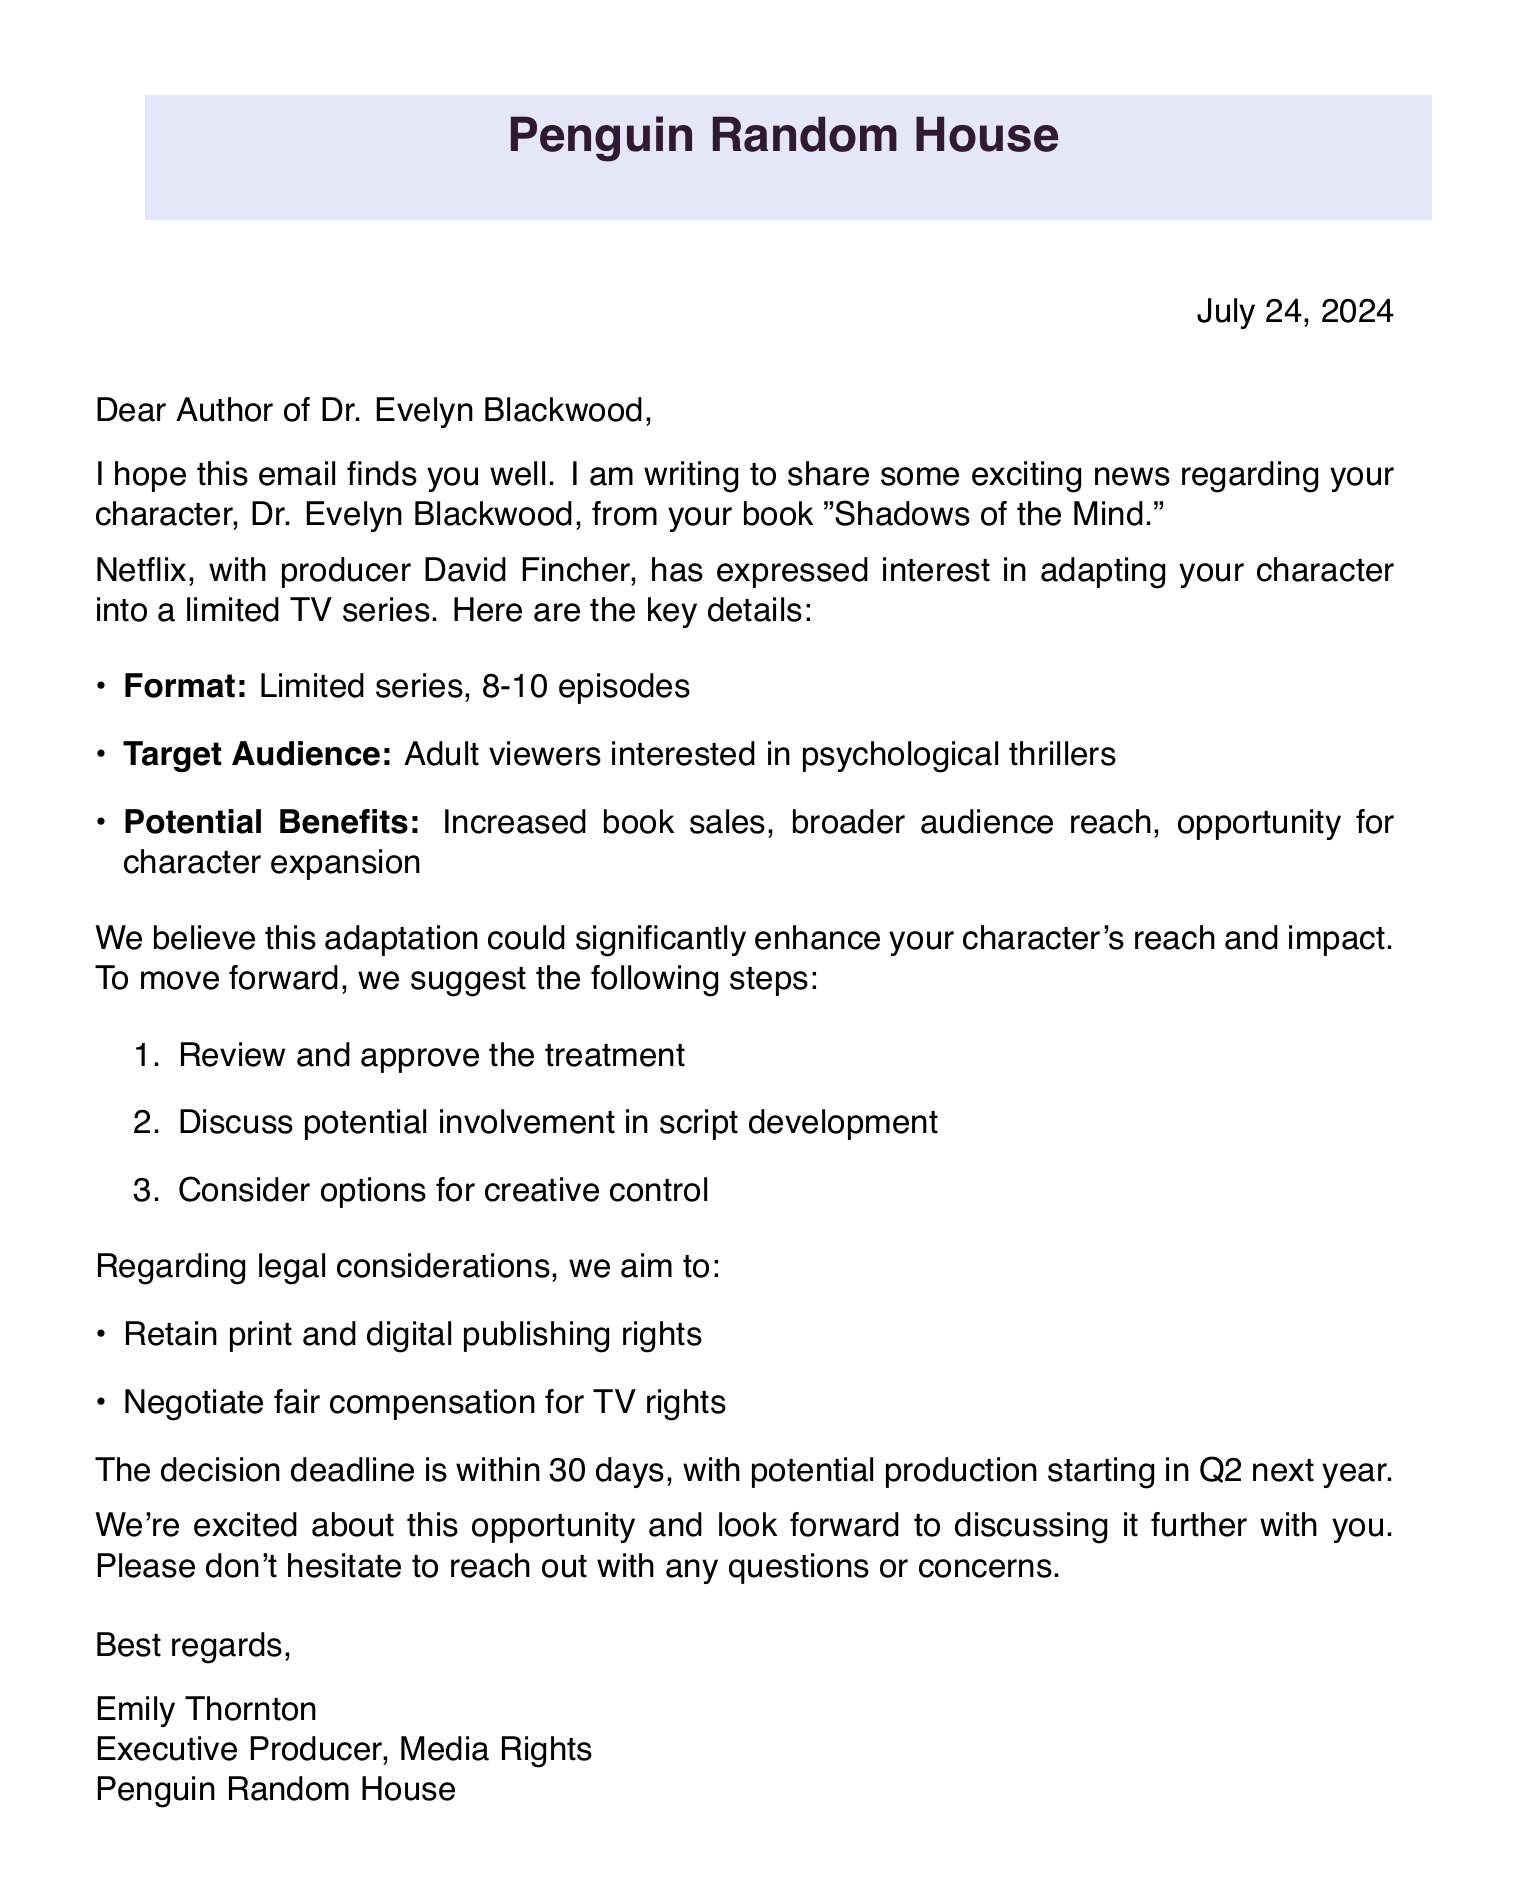What is the subject of the email? The subject line in the document clearly states the main topic being addressed in the email.
Answer: Exciting News: Potential TV Adaptation for Your Character Who is the contact person? The document identifies the individual you'd communicate with regarding the adaptation, specifically for their role at Penguin Random House.
Answer: Emily Thornton What is the name of the character? The email directly refers to the character that is the focus of the potential adaptation.
Answer: Dr. Evelyn Blackwood How many episodes are proposed for the adaptation? The document specifies the range of episodes intended for the limited series.
Answer: 8-10 What is one potential benefit mentioned in the email? The email lists various advantages of the adaptation, which can be retrieved from the provided bullet points.
Answer: Increased book sales What is the decision deadline mentioned? The email specifies the timeframe in which a decision regarding the adaptation should be made.
Answer: Within 30 days Which company is interested in the adaptation? The email states the production company that has shown interest in adapting the character.
Answer: Netflix Who is the producer associated with the project? The document includes the name of the producer likely to be involved in the adaptation process.
Answer: David Fincher What rights will be retained according to the legal considerations? The email addresses the rights related to the publishing of the character, which is crucial for content ownership.
Answer: Retain print and digital publishing rights 